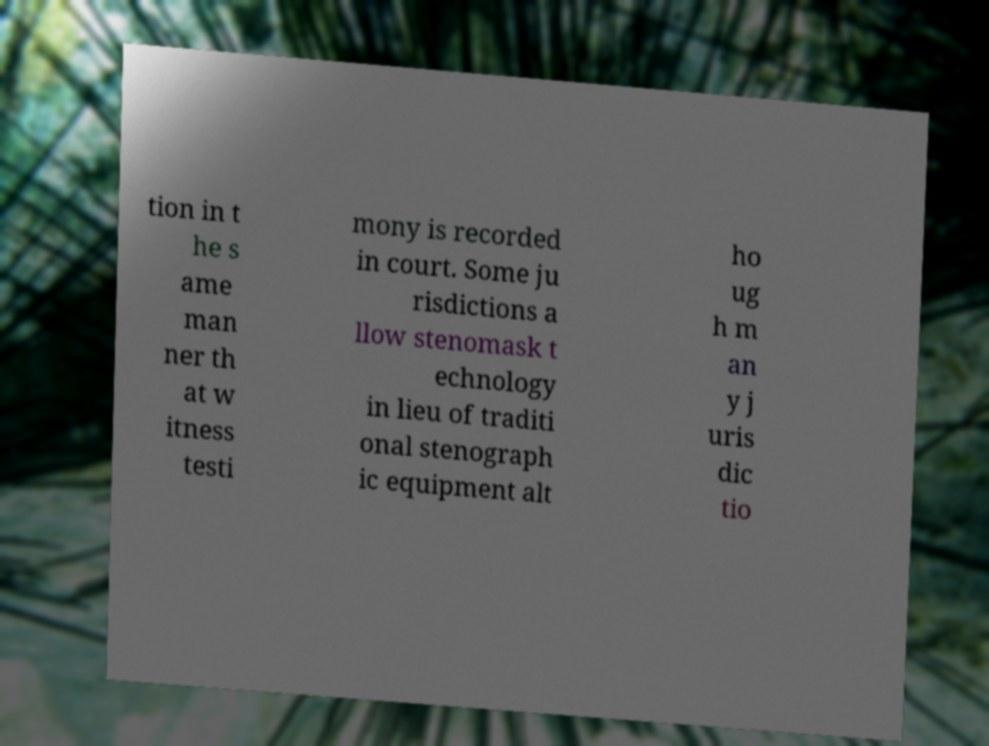Could you assist in decoding the text presented in this image and type it out clearly? tion in t he s ame man ner th at w itness testi mony is recorded in court. Some ju risdictions a llow stenomask t echnology in lieu of traditi onal stenograph ic equipment alt ho ug h m an y j uris dic tio 